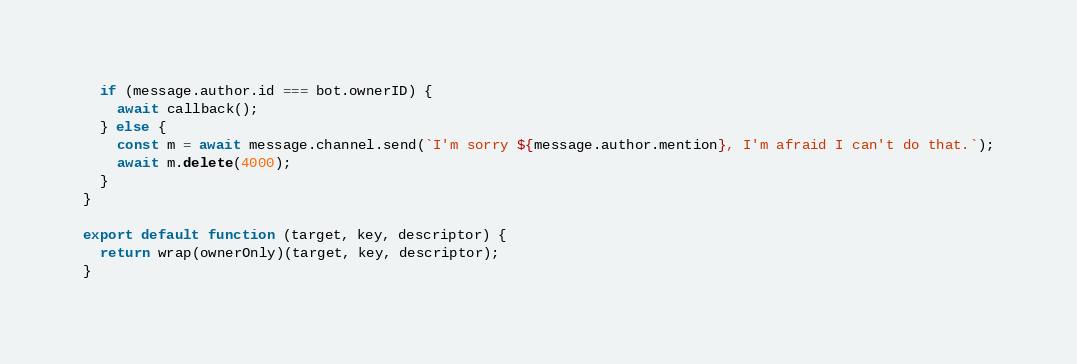Convert code to text. <code><loc_0><loc_0><loc_500><loc_500><_JavaScript_>
  if (message.author.id === bot.ownerID) {
    await callback();
  } else {
    const m = await message.channel.send(`I'm sorry ${message.author.mention}, I'm afraid I can't do that.`);
    await m.delete(4000);
  }
}

export default function (target, key, descriptor) {
  return wrap(ownerOnly)(target, key, descriptor);
}</code> 